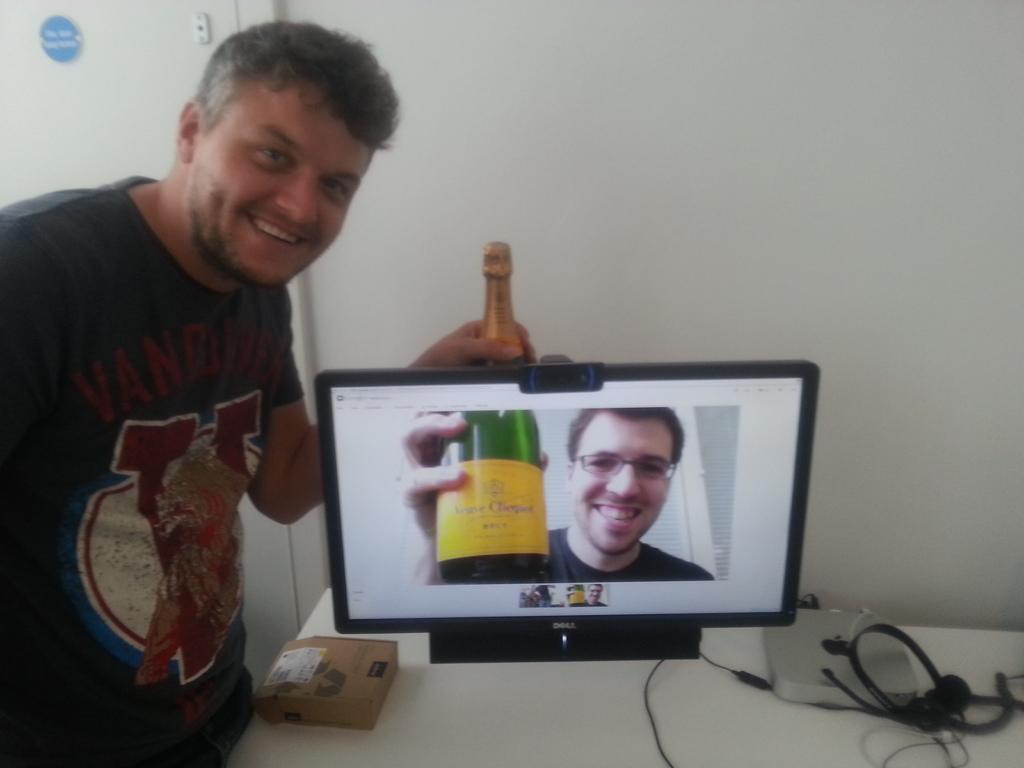Please provide a concise description of this image. In this picture I can observe a person standing on the left side. The person is wearing T shirt and he is smiling. He is holding a champagne in this hand. There is a monitor on the desk. In the monitor I can observe a person holding a champagne. On the right side there is a headset. In the background I can observe a wall. 